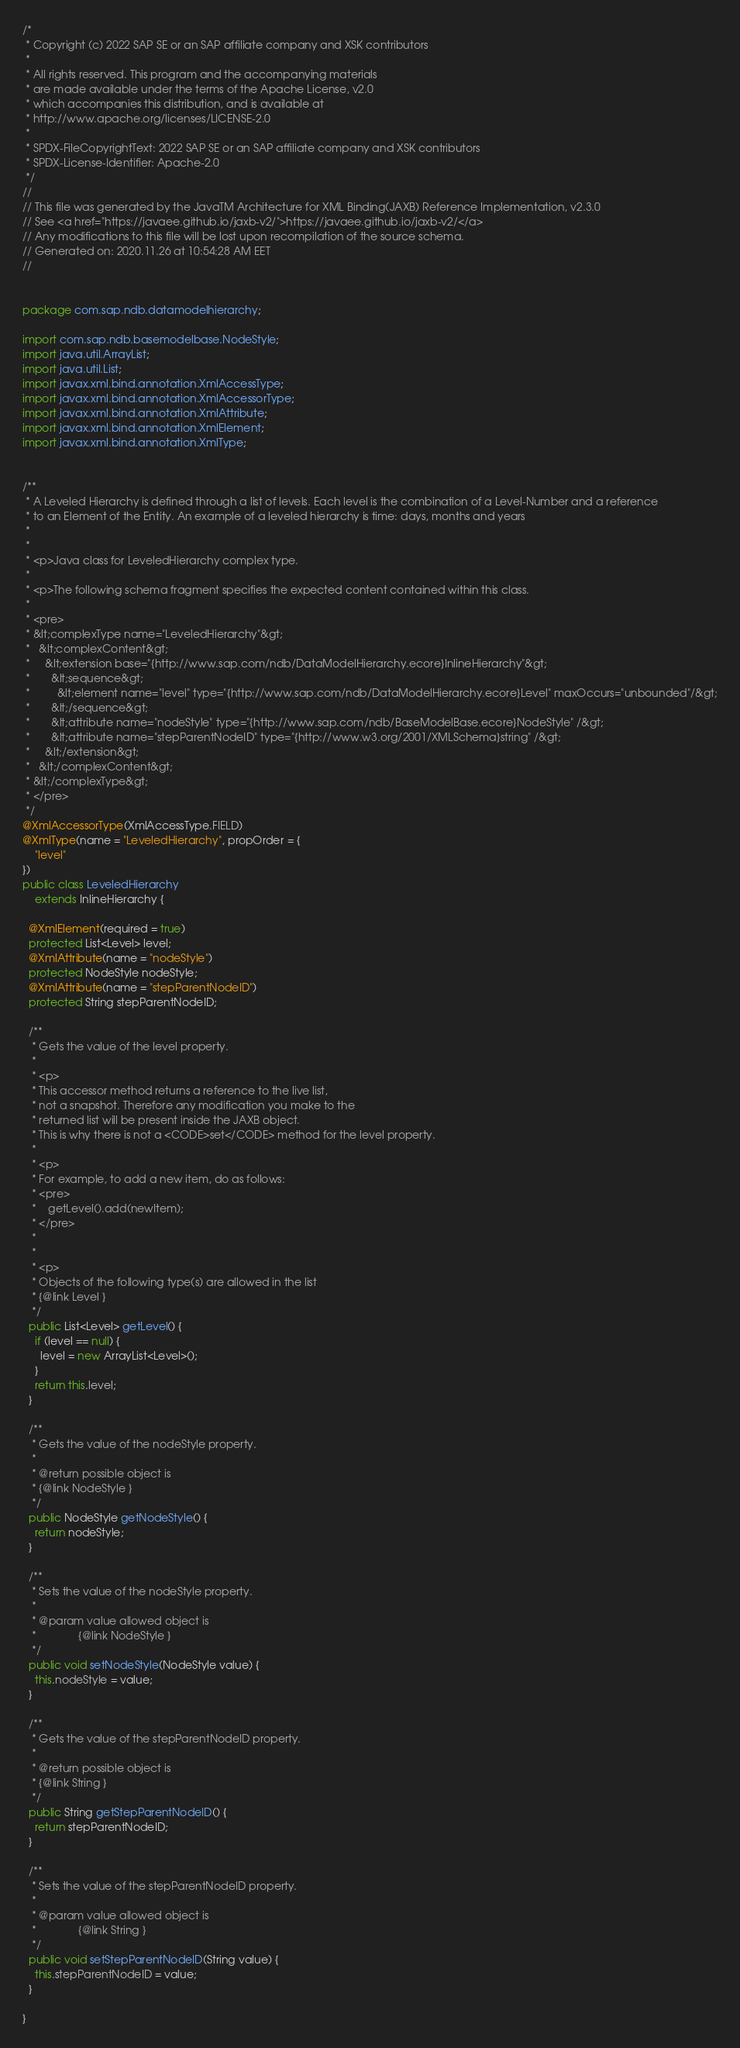Convert code to text. <code><loc_0><loc_0><loc_500><loc_500><_Java_>/*
 * Copyright (c) 2022 SAP SE or an SAP affiliate company and XSK contributors
 *
 * All rights reserved. This program and the accompanying materials
 * are made available under the terms of the Apache License, v2.0
 * which accompanies this distribution, and is available at
 * http://www.apache.org/licenses/LICENSE-2.0
 *
 * SPDX-FileCopyrightText: 2022 SAP SE or an SAP affiliate company and XSK contributors
 * SPDX-License-Identifier: Apache-2.0
 */
//
// This file was generated by the JavaTM Architecture for XML Binding(JAXB) Reference Implementation, v2.3.0 
// See <a href="https://javaee.github.io/jaxb-v2/">https://javaee.github.io/jaxb-v2/</a> 
// Any modifications to this file will be lost upon recompilation of the source schema. 
// Generated on: 2020.11.26 at 10:54:28 AM EET 
//


package com.sap.ndb.datamodelhierarchy;

import com.sap.ndb.basemodelbase.NodeStyle;
import java.util.ArrayList;
import java.util.List;
import javax.xml.bind.annotation.XmlAccessType;
import javax.xml.bind.annotation.XmlAccessorType;
import javax.xml.bind.annotation.XmlAttribute;
import javax.xml.bind.annotation.XmlElement;
import javax.xml.bind.annotation.XmlType;


/**
 * A Leveled Hierarchy is defined through a list of levels. Each level is the combination of a Level-Number and a reference
 * to an Element of the Entity. An example of a	leveled hierarchy is time: days, months and years
 *
 *
 * <p>Java class for LeveledHierarchy complex type.
 *
 * <p>The following schema fragment specifies the expected content contained within this class.
 *
 * <pre>
 * &lt;complexType name="LeveledHierarchy"&gt;
 *   &lt;complexContent&gt;
 *     &lt;extension base="{http://www.sap.com/ndb/DataModelHierarchy.ecore}InlineHierarchy"&gt;
 *       &lt;sequence&gt;
 *         &lt;element name="level" type="{http://www.sap.com/ndb/DataModelHierarchy.ecore}Level" maxOccurs="unbounded"/&gt;
 *       &lt;/sequence&gt;
 *       &lt;attribute name="nodeStyle" type="{http://www.sap.com/ndb/BaseModelBase.ecore}NodeStyle" /&gt;
 *       &lt;attribute name="stepParentNodeID" type="{http://www.w3.org/2001/XMLSchema}string" /&gt;
 *     &lt;/extension&gt;
 *   &lt;/complexContent&gt;
 * &lt;/complexType&gt;
 * </pre>
 */
@XmlAccessorType(XmlAccessType.FIELD)
@XmlType(name = "LeveledHierarchy", propOrder = {
    "level"
})
public class LeveledHierarchy
    extends InlineHierarchy {

  @XmlElement(required = true)
  protected List<Level> level;
  @XmlAttribute(name = "nodeStyle")
  protected NodeStyle nodeStyle;
  @XmlAttribute(name = "stepParentNodeID")
  protected String stepParentNodeID;

  /**
   * Gets the value of the level property.
   *
   * <p>
   * This accessor method returns a reference to the live list,
   * not a snapshot. Therefore any modification you make to the
   * returned list will be present inside the JAXB object.
   * This is why there is not a <CODE>set</CODE> method for the level property.
   *
   * <p>
   * For example, to add a new item, do as follows:
   * <pre>
   *    getLevel().add(newItem);
   * </pre>
   *
   *
   * <p>
   * Objects of the following type(s) are allowed in the list
   * {@link Level }
   */
  public List<Level> getLevel() {
    if (level == null) {
      level = new ArrayList<Level>();
    }
    return this.level;
  }

  /**
   * Gets the value of the nodeStyle property.
   *
   * @return possible object is
   * {@link NodeStyle }
   */
  public NodeStyle getNodeStyle() {
    return nodeStyle;
  }

  /**
   * Sets the value of the nodeStyle property.
   *
   * @param value allowed object is
   *              {@link NodeStyle }
   */
  public void setNodeStyle(NodeStyle value) {
    this.nodeStyle = value;
  }

  /**
   * Gets the value of the stepParentNodeID property.
   *
   * @return possible object is
   * {@link String }
   */
  public String getStepParentNodeID() {
    return stepParentNodeID;
  }

  /**
   * Sets the value of the stepParentNodeID property.
   *
   * @param value allowed object is
   *              {@link String }
   */
  public void setStepParentNodeID(String value) {
    this.stepParentNodeID = value;
  }

}
</code> 